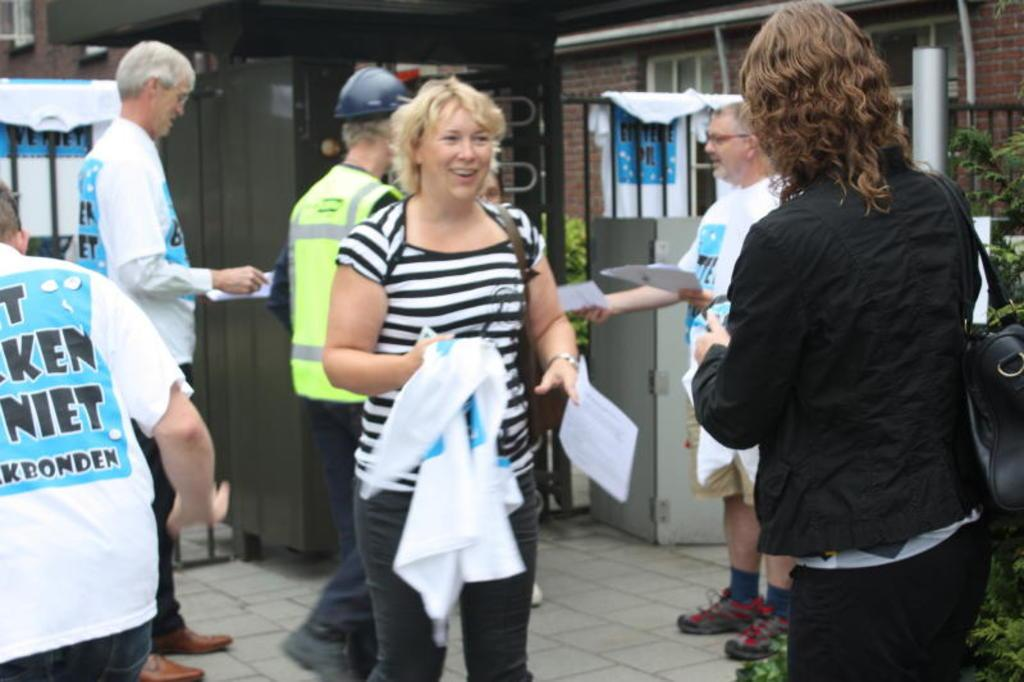What are the people in the image doing? The people in the image are standing and holding objects. What type of natural elements can be seen in the image? There are plants in the image. What type of man-made structures are visible in the image? There are buildings in the image. What type of clothing can be seen in the image? There are clothes in the image. What type of barrier is present in the image? There is a fence in the image. What other objects can be seen on the ground in the image? There are other objects on the ground in the image. Where is the basin located in the image? There is no basin present in the image. What type of crook can be seen in the image? There is no crook present in the image. 